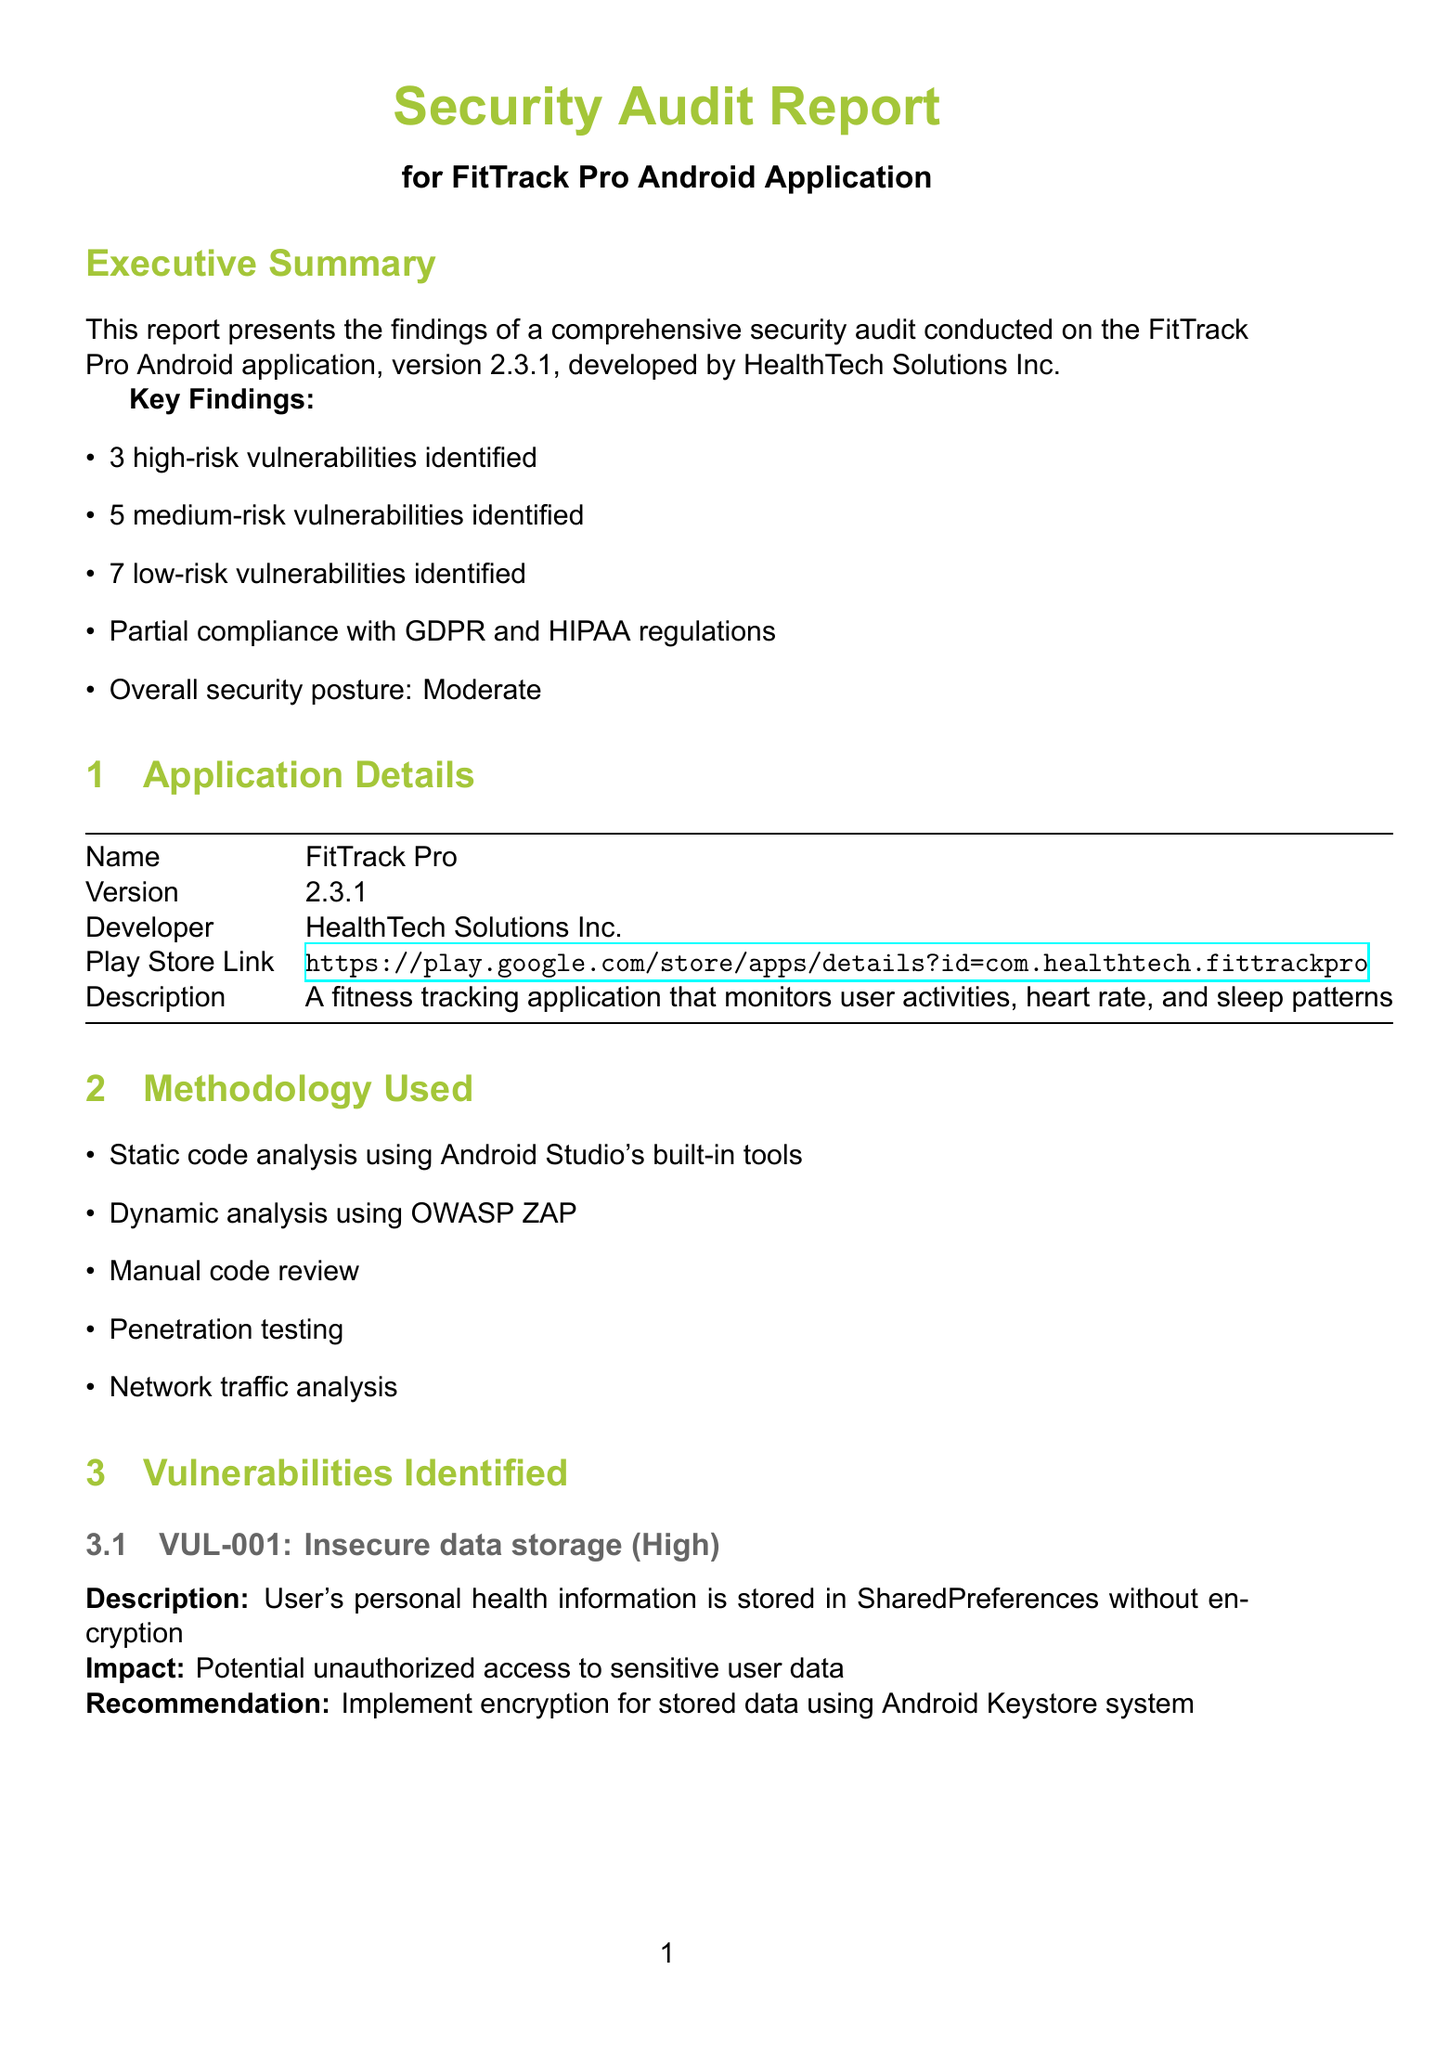what is the version of the FitTrack Pro application? The version of the application is stated in the Application Details section of the report.
Answer: 2.3.1 how many high-risk vulnerabilities were identified? The number of high-risk vulnerabilities is summarized in the Key Findings section of the report.
Answer: 3 what recommendations are made for insecure data storage? The recommendations for insecure data storage are detailed in the Vulnerabilities Identified section.
Answer: Implement encryption for stored data using Android Keystore system what is the compliance status with HIPAA regulations? The compliance status with HIPAA is mentioned in the Compliance Status section.
Answer: Partial compliance how many suggested improvements are there in total? The total number of suggested improvements can be derived from the Suggested Improvements section, where each category contains suggestions.
Answer: 6 what is the impact of allowing weak passwords? The impact of weak passwords is described in the Vulnerabilities Identified section under the Medium severity vulnerability.
Answer: Increased risk of unauthorized access through brute-force attacks what is the overall security posture of FitTrack Pro? The overall security posture is mentioned in the Key Findings part of the executive summary.
Answer: Moderate which method was used for penetration testing? The method used for penetration testing is one of the methodologies outlined in the Methodology Used section.
Answer: Penetration testing what is the recommended timeframe to address high-risk vulnerabilities? The timeframe to address high-risk vulnerabilities is specified in the Conclusion and Next Steps section.
Answer: Within 2 weeks 